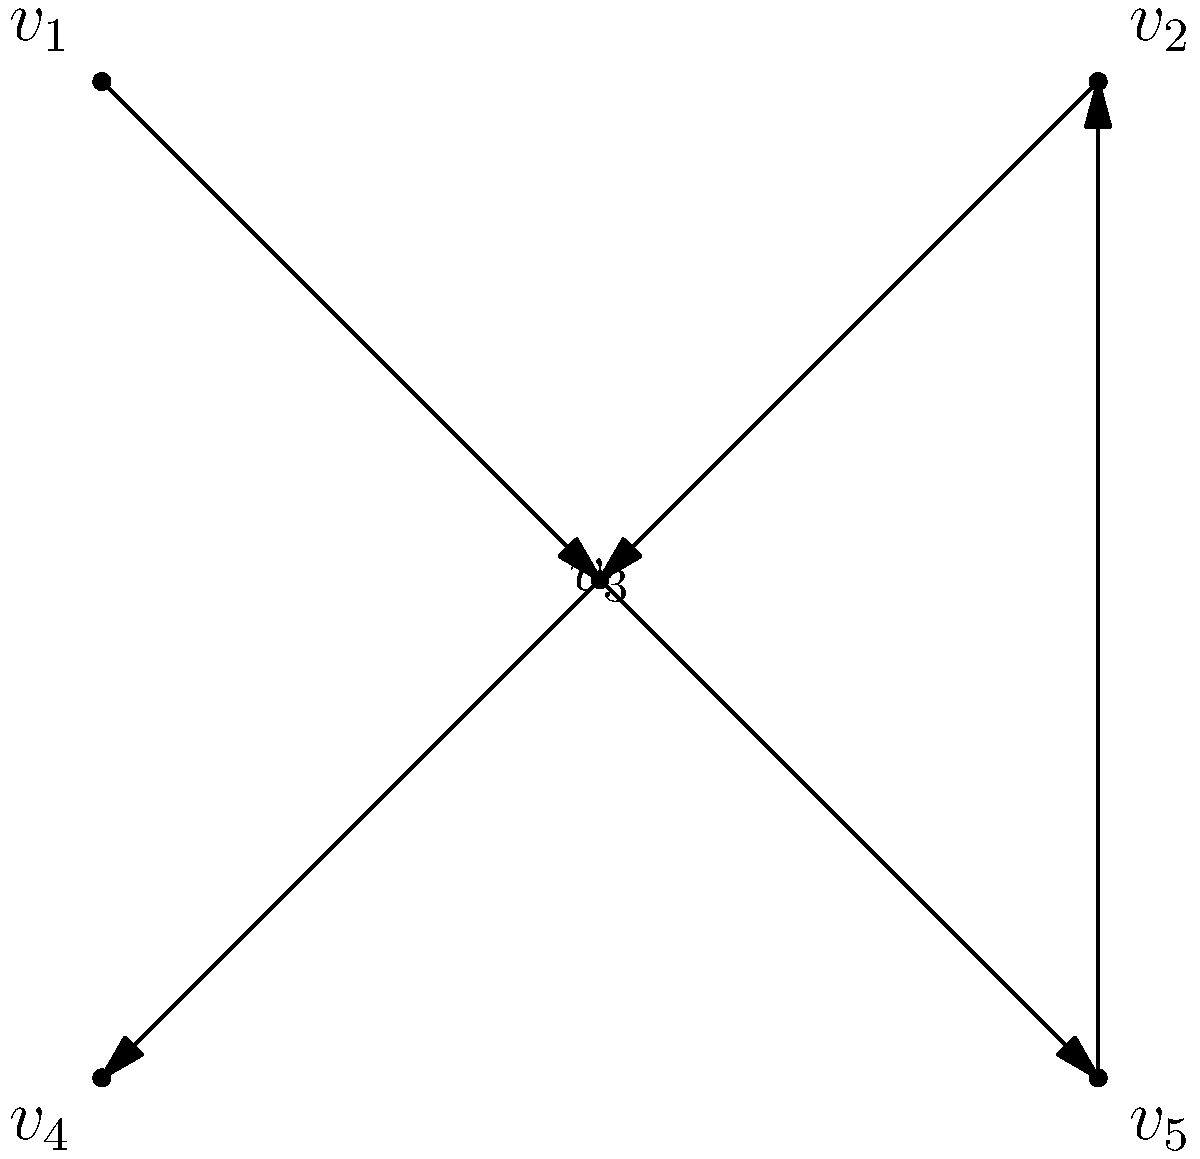In the context of detecting cycles in a directed graph representing data dependencies in a repository, consider the graph shown above. Which algorithm would be most efficient to determine if this graph contains a cycle, and what would be its result? To efficiently detect cycles in a directed graph, we can use Depth-First Search (DFS) algorithm. Here's how we can apply it to this graph:

1. Start DFS from any vertex, let's choose $v_1$.
2. Mark $v_1$ as visited and add it to the recursion stack.
3. Explore $v_1$'s only neighbor, $v_3$. Mark $v_3$ as visited and add it to the stack.
4. From $v_3$, we can go to $v_4$ or $v_5$. Let's choose $v_4$.
5. Mark $v_4$ as visited. It has no unvisited neighbors, so backtrack to $v_3$.
6. From $v_3$, visit $v_5$. Mark it as visited and add to the stack.
7. From $v_5$, we can visit $v_2$. Mark $v_2$ as visited and add to the stack.
8. From $v_2$, we can visit $v_3$. However, $v_3$ is already in our recursion stack.

When we encounter a vertex that's already in our recursion stack, we've found a cycle.

The cycle in this graph is: $v_3 \rightarrow v_5 \rightarrow v_2 \rightarrow v_3$

DFS has a time complexity of $O(V+E)$ where $V$ is the number of vertices and $E$ is the number of edges, making it efficient for this task.
Answer: DFS; cycle detected ($v_3 \rightarrow v_5 \rightarrow v_2 \rightarrow v_3$) 